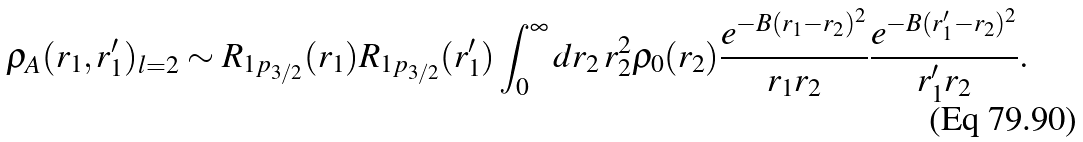<formula> <loc_0><loc_0><loc_500><loc_500>\rho _ { A } ( r _ { 1 } , r ^ { \prime } _ { 1 } ) _ { l = 2 } \sim R _ { 1 p _ { 3 / 2 } } ( r _ { 1 } ) R _ { 1 p _ { 3 / 2 } } ( r ^ { \prime } _ { 1 } ) \int _ { 0 } ^ { \infty } d r _ { 2 } \, r _ { 2 } ^ { 2 } \rho _ { 0 } ( r _ { 2 } ) \frac { e ^ { - B ( r _ { 1 } - r _ { 2 } ) ^ { 2 } } } { r _ { 1 } r _ { 2 } } \frac { e ^ { - B ( r ^ { \prime } _ { 1 } - r _ { 2 } ) ^ { 2 } } } { r ^ { \prime } _ { 1 } r _ { 2 } } .</formula> 